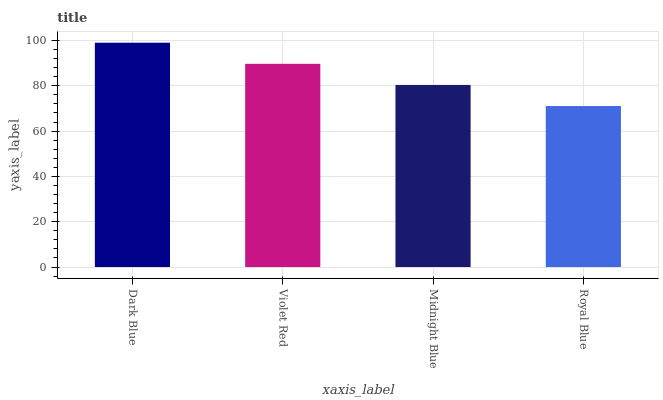Is Royal Blue the minimum?
Answer yes or no. Yes. Is Dark Blue the maximum?
Answer yes or no. Yes. Is Violet Red the minimum?
Answer yes or no. No. Is Violet Red the maximum?
Answer yes or no. No. Is Dark Blue greater than Violet Red?
Answer yes or no. Yes. Is Violet Red less than Dark Blue?
Answer yes or no. Yes. Is Violet Red greater than Dark Blue?
Answer yes or no. No. Is Dark Blue less than Violet Red?
Answer yes or no. No. Is Violet Red the high median?
Answer yes or no. Yes. Is Midnight Blue the low median?
Answer yes or no. Yes. Is Midnight Blue the high median?
Answer yes or no. No. Is Royal Blue the low median?
Answer yes or no. No. 